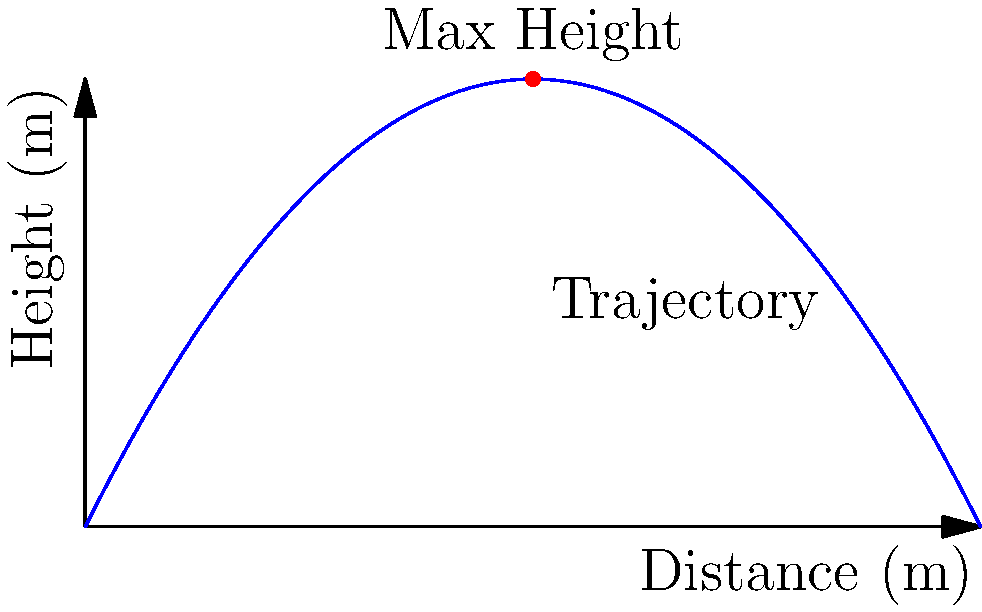In a historical battle scene, you're tasked with calculating the trajectory of a prop catapult. The path of the projectile can be modeled by the function $h(d) = -0.05d^2 + 2d$, where $h$ is the height in meters and $d$ is the horizontal distance in meters. What is the maximum height reached by the projectile, and at what horizontal distance does this occur? To find the maximum height and its corresponding horizontal distance, we need to follow these steps:

1) The maximum height occurs at the vertex of the parabola. For a quadratic function in the form $f(x) = ax^2 + bx + c$, the x-coordinate of the vertex is given by $x = -\frac{b}{2a}$.

2) In our function $h(d) = -0.05d^2 + 2d$, we have:
   $a = -0.05$
   $b = 2$
   $c = 0$

3) Calculating the horizontal distance at maximum height:
   $d = -\frac{b}{2a} = -\frac{2}{2(-0.05)} = \frac{2}{0.1} = 20$ meters

4) To find the maximum height, we substitute this d-value into our original function:
   $h(20) = -0.05(20)^2 + 2(20)$
   $= -0.05(400) + 40$
   $= -20 + 40$
   $= 20$ meters

Therefore, the maximum height is 20 meters, occurring at a horizontal distance of 20 meters.
Answer: 20 m height at 20 m distance 